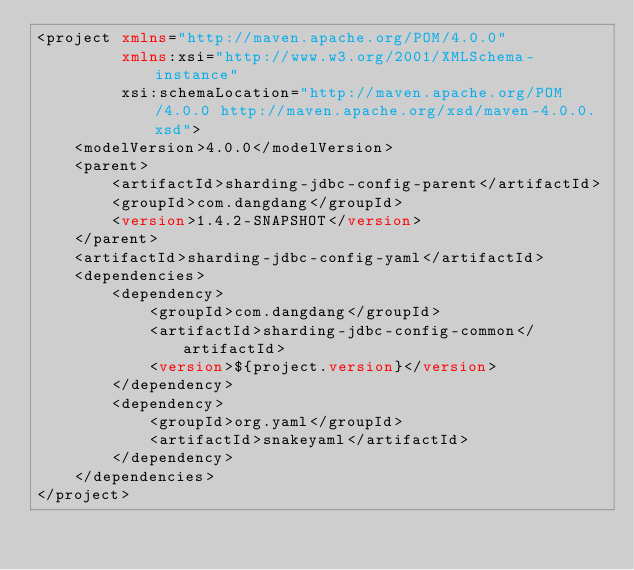Convert code to text. <code><loc_0><loc_0><loc_500><loc_500><_XML_><project xmlns="http://maven.apache.org/POM/4.0.0"
         xmlns:xsi="http://www.w3.org/2001/XMLSchema-instance"
         xsi:schemaLocation="http://maven.apache.org/POM/4.0.0 http://maven.apache.org/xsd/maven-4.0.0.xsd">
    <modelVersion>4.0.0</modelVersion>
    <parent>
        <artifactId>sharding-jdbc-config-parent</artifactId>
        <groupId>com.dangdang</groupId>
        <version>1.4.2-SNAPSHOT</version>
    </parent>
    <artifactId>sharding-jdbc-config-yaml</artifactId>
    <dependencies>
        <dependency>
            <groupId>com.dangdang</groupId>
            <artifactId>sharding-jdbc-config-common</artifactId>
            <version>${project.version}</version>
        </dependency>
        <dependency>
            <groupId>org.yaml</groupId>
            <artifactId>snakeyaml</artifactId>
        </dependency>
    </dependencies>
</project></code> 